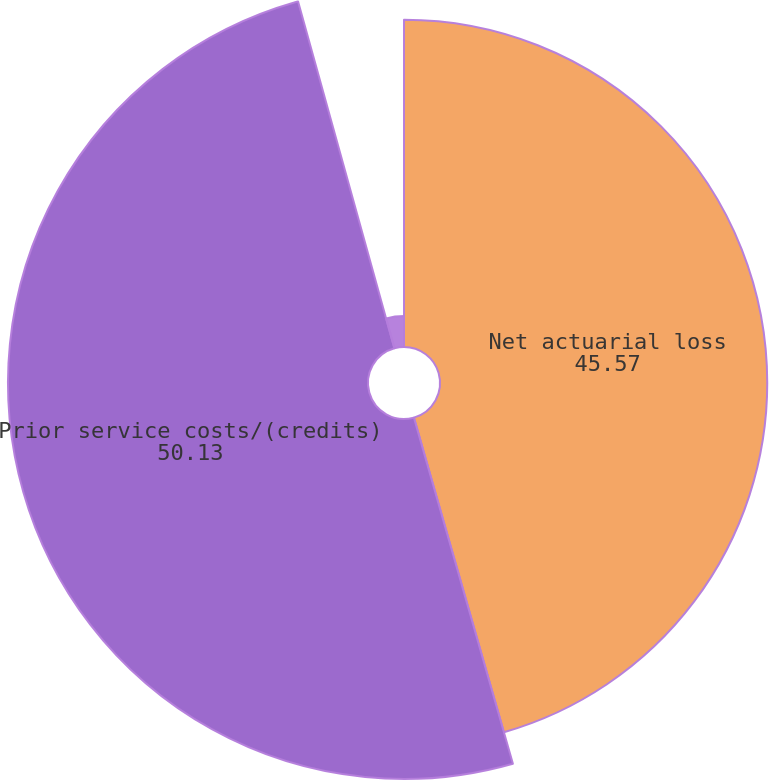<chart> <loc_0><loc_0><loc_500><loc_500><pie_chart><fcel>Net actuarial loss<fcel>Prior service costs/(credits)<fcel>Total recognized in<nl><fcel>45.57%<fcel>50.13%<fcel>4.31%<nl></chart> 